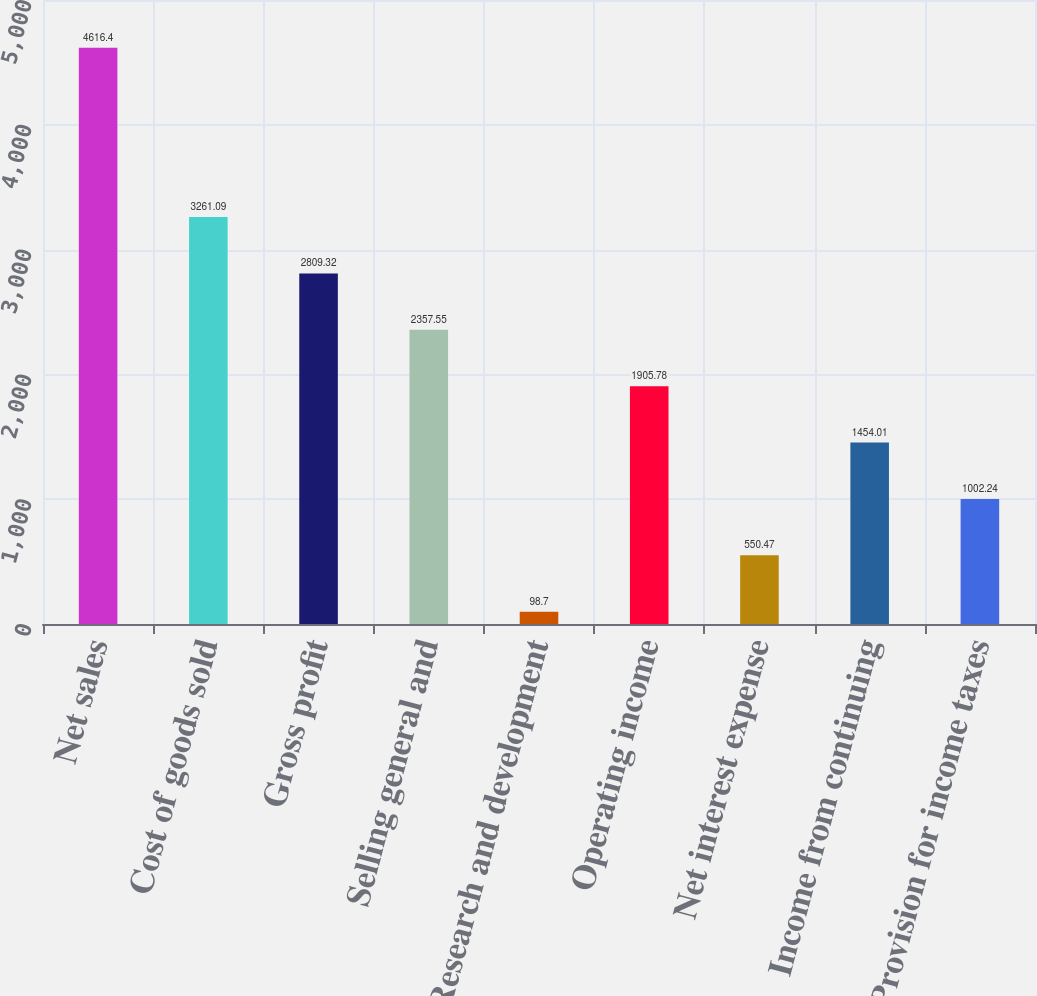Convert chart. <chart><loc_0><loc_0><loc_500><loc_500><bar_chart><fcel>Net sales<fcel>Cost of goods sold<fcel>Gross profit<fcel>Selling general and<fcel>Research and development<fcel>Operating income<fcel>Net interest expense<fcel>Income from continuing<fcel>Provision for income taxes<nl><fcel>4616.4<fcel>3261.09<fcel>2809.32<fcel>2357.55<fcel>98.7<fcel>1905.78<fcel>550.47<fcel>1454.01<fcel>1002.24<nl></chart> 